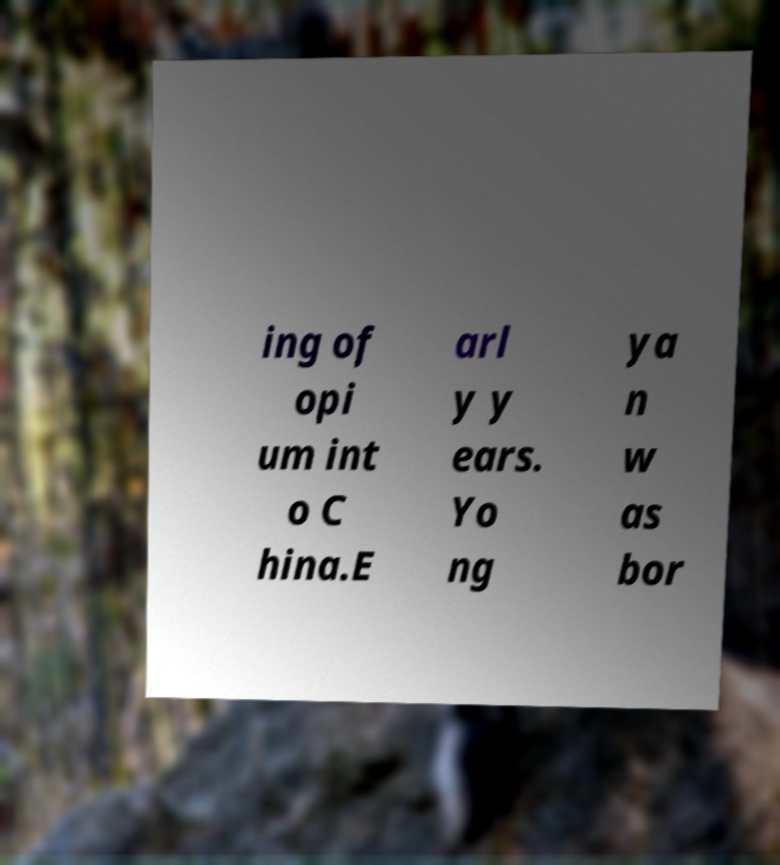I need the written content from this picture converted into text. Can you do that? ing of opi um int o C hina.E arl y y ears. Yo ng ya n w as bor 